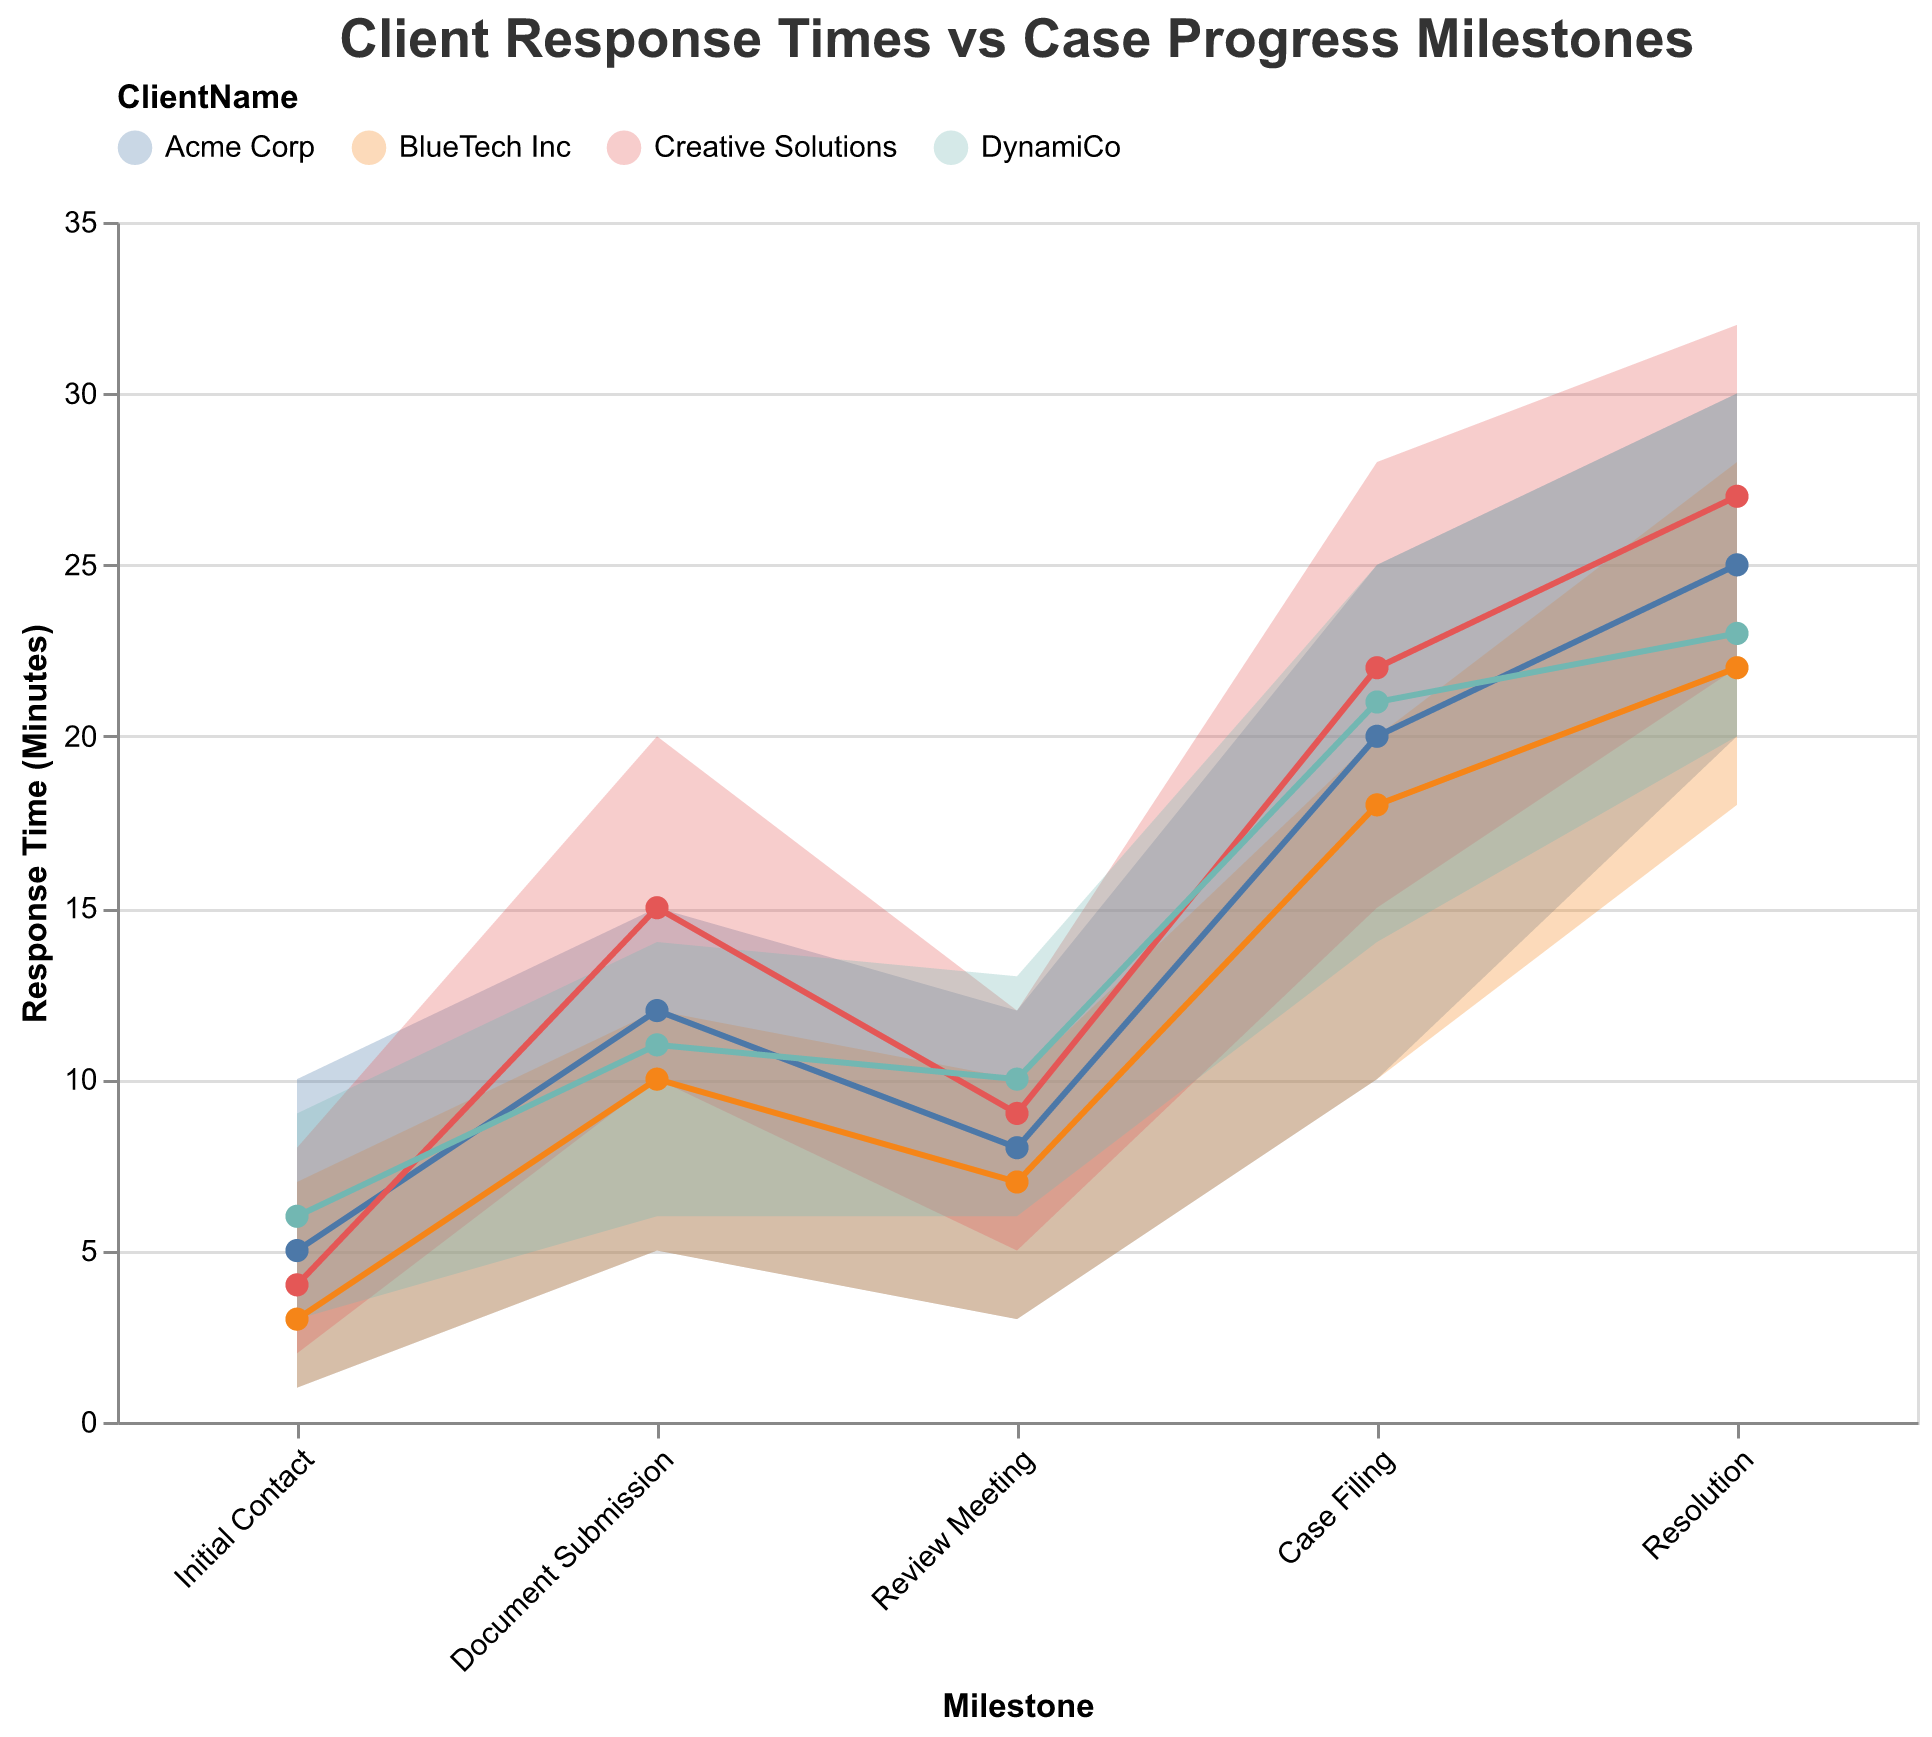How many distinct clients are represented in the chart? The chart has different colors for each client, and we can inspect the legend to count the distinct clients listed.
Answer: 4 What is the general trend of response times across milestones for Creative Solutions? By observing the response times (marked by the line with points) across milestones for Creative Solutions, we can see an increasing trend from 'Initial Contact' to 'Resolution'.
Answer: Increasing trend For the initial contact milestone, which client took the longest to respond? By comparing the response times for the ‘Initial Contact’ milestone in the chart, we see that DynamiCo has the highest response time.
Answer: DynamiCo What's the average maximum response time at the 'Resolution' milestone across all clients? The maximum times at 'Resolution' for all clients are 30, 28, 32, and 30. The average is (30 + 28 + 32 + 30) / 4 = 30.
Answer: 30 Which milestone has the greatest variability in response times for Acme Corp? The variability can be determined by the range (difference between max and min times). For Acme Corp, the ranges are: Initial Contact (10-1)=9, Document Submission (15-5)=10, Review Meeting (12-3)=9, Case Filing (25-10)=15, Resolution (30-20)=10. The greatest is at 'Case Filing'.
Answer: Case Filing How does the actual response time for BlueTech Inc. at the 'Review Meeting' milestone compare to the expected range? For BlueTech Inc., the actual response time at 'Review Meeting' is 7, and the expected range is 3 to 10. The actual time falls within this range.
Answer: Within range Among all the clients, who responded the fastest during the 'Document Submission' milestone? Comparing the response times for 'Document Submission', BlueTech Inc. responded the fastest with a time of 10 minutes.
Answer: BlueTech Inc What is the total range of expected times for the 'Case Filing' milestone for all clients? Adding the ranges, we get: Acme Corp(15), BlueTech Inc(10), Creative Solutions(13), and DynamiCo(11). The total range = 15 + 10 + 13 + 11 = 49 minutes.
Answer: 49 minutes Which client shows the least deviation from the maximum expected time during the 'Review Meeting' milestone? By comparing the difference between actual response times and maximum expected times for each client at 'Review Meeting': Acme Corp(12-8=4), BlueTech Inc(10-7=3), Creative Solutions(12-9=3), DynamiCo(13-10=3). The smallest deviations are 3 minutes (BlueTech Inc, Creative Solutions, and DynamiCo).
Answer: BlueTech Inc, Creative Solutions, DynamiCo Does DynamiCo take more than 10 minutes for any milestone apart from 'Case Filing' and 'Resolution'? Checking DynamiCo’s response times for each milestone, we find that only ‘Document Submission’ (11) and ‘Review Meeting’ (10) exceed 10 minutes besides 'Case Filing' and 'Resolution'.
Answer: Yes, 'Document Submission' and 'Review Meeting' 